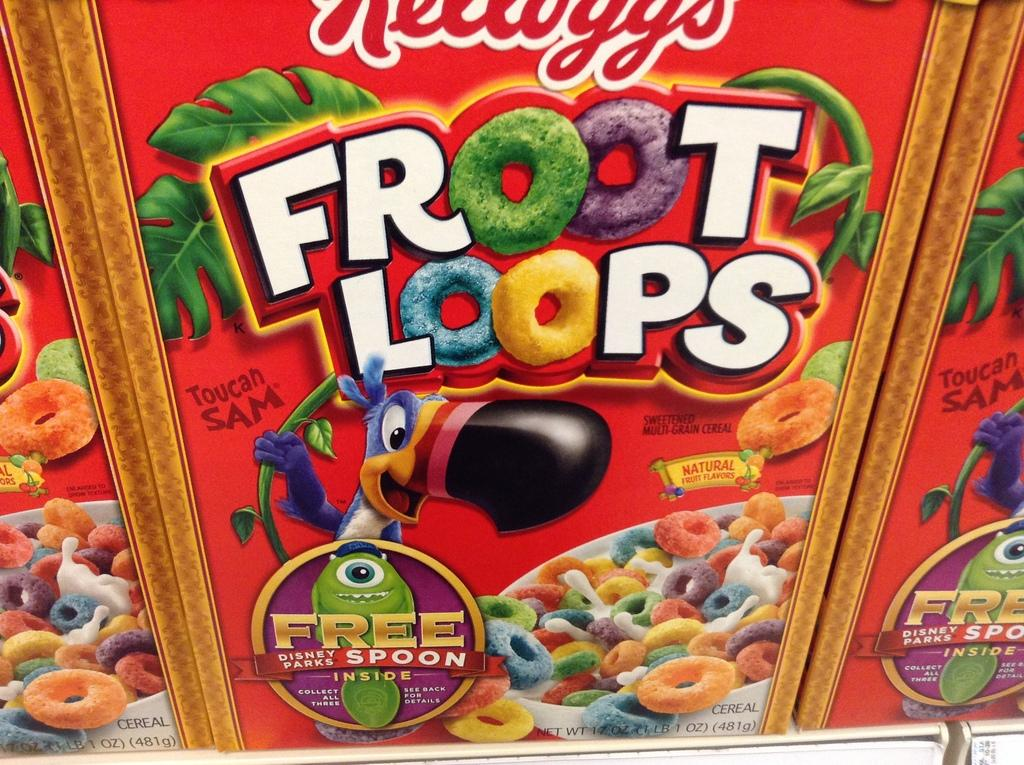What object is present in the image? There is a box in the image. What is written on the box? The word "Froot loops" is written on the box. What type of illustrations are on the box? There are cartoons on the box. How many girls are playing on the slope in the image? There are no girls or slopes present in the image; it features a box with the word "Froot loops" and cartoons. 